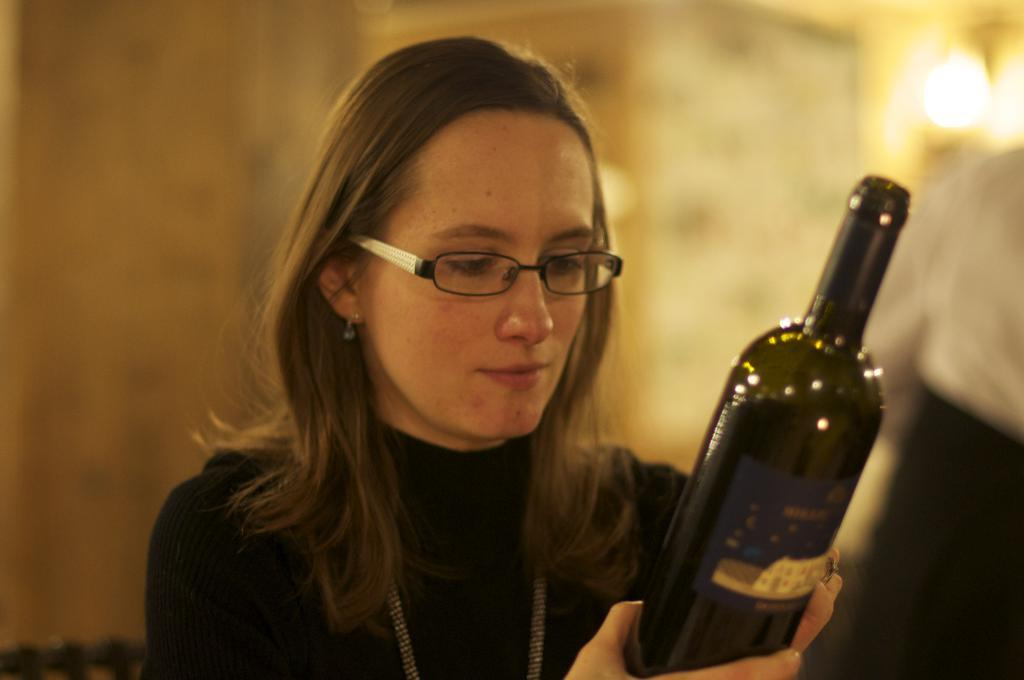Who is present in the image? There is a woman in the image. What is the woman doing in the image? A: The woman is smiling in the image. What is the woman holding in her hand? The woman is holding a bottle in her hand. What can be seen in the background of the image? There is a wall and a light in the background of the image. How many frogs are present in the image, and what are they regretting? There are no frogs present in the image, and they cannot have feelings of regret. 